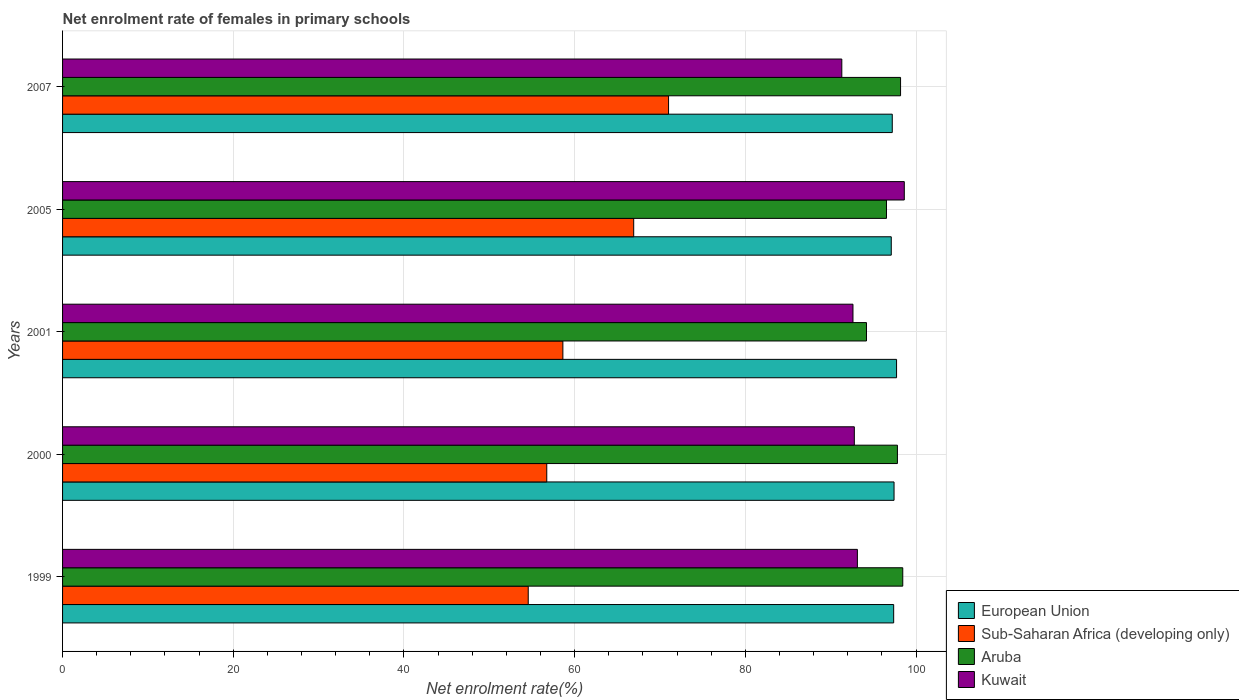How many groups of bars are there?
Provide a short and direct response. 5. Are the number of bars on each tick of the Y-axis equal?
Offer a terse response. Yes. What is the net enrolment rate of females in primary schools in Sub-Saharan Africa (developing only) in 2007?
Keep it short and to the point. 71.01. Across all years, what is the maximum net enrolment rate of females in primary schools in Kuwait?
Offer a very short reply. 98.63. Across all years, what is the minimum net enrolment rate of females in primary schools in Kuwait?
Ensure brevity in your answer.  91.31. In which year was the net enrolment rate of females in primary schools in Aruba maximum?
Keep it short and to the point. 1999. In which year was the net enrolment rate of females in primary schools in European Union minimum?
Keep it short and to the point. 2005. What is the total net enrolment rate of females in primary schools in Sub-Saharan Africa (developing only) in the graph?
Ensure brevity in your answer.  307.85. What is the difference between the net enrolment rate of females in primary schools in European Union in 2000 and that in 2005?
Provide a succinct answer. 0.33. What is the difference between the net enrolment rate of females in primary schools in Kuwait in 2007 and the net enrolment rate of females in primary schools in Aruba in 2001?
Provide a short and direct response. -2.89. What is the average net enrolment rate of females in primary schools in Kuwait per year?
Provide a short and direct response. 93.69. In the year 1999, what is the difference between the net enrolment rate of females in primary schools in Sub-Saharan Africa (developing only) and net enrolment rate of females in primary schools in European Union?
Provide a succinct answer. -42.82. In how many years, is the net enrolment rate of females in primary schools in Sub-Saharan Africa (developing only) greater than 64 %?
Give a very brief answer. 2. What is the ratio of the net enrolment rate of females in primary schools in Sub-Saharan Africa (developing only) in 2001 to that in 2005?
Offer a very short reply. 0.88. What is the difference between the highest and the second highest net enrolment rate of females in primary schools in European Union?
Keep it short and to the point. 0.3. What is the difference between the highest and the lowest net enrolment rate of females in primary schools in Sub-Saharan Africa (developing only)?
Offer a very short reply. 16.44. Is the sum of the net enrolment rate of females in primary schools in European Union in 2000 and 2001 greater than the maximum net enrolment rate of females in primary schools in Sub-Saharan Africa (developing only) across all years?
Your answer should be very brief. Yes. What does the 1st bar from the top in 2000 represents?
Your answer should be very brief. Kuwait. What does the 3rd bar from the bottom in 2000 represents?
Ensure brevity in your answer.  Aruba. How many bars are there?
Make the answer very short. 20. What is the difference between two consecutive major ticks on the X-axis?
Your answer should be very brief. 20. Does the graph contain any zero values?
Keep it short and to the point. No. Where does the legend appear in the graph?
Make the answer very short. Bottom right. What is the title of the graph?
Ensure brevity in your answer.  Net enrolment rate of females in primary schools. Does "Mexico" appear as one of the legend labels in the graph?
Make the answer very short. No. What is the label or title of the X-axis?
Offer a terse response. Net enrolment rate(%). What is the label or title of the Y-axis?
Ensure brevity in your answer.  Years. What is the Net enrolment rate(%) in European Union in 1999?
Offer a very short reply. 97.38. What is the Net enrolment rate(%) of Sub-Saharan Africa (developing only) in 1999?
Offer a very short reply. 54.56. What is the Net enrolment rate(%) in Aruba in 1999?
Keep it short and to the point. 98.45. What is the Net enrolment rate(%) in Kuwait in 1999?
Your response must be concise. 93.13. What is the Net enrolment rate(%) of European Union in 2000?
Offer a terse response. 97.43. What is the Net enrolment rate(%) of Sub-Saharan Africa (developing only) in 2000?
Keep it short and to the point. 56.74. What is the Net enrolment rate(%) of Aruba in 2000?
Make the answer very short. 97.82. What is the Net enrolment rate(%) of Kuwait in 2000?
Provide a succinct answer. 92.77. What is the Net enrolment rate(%) in European Union in 2001?
Offer a terse response. 97.72. What is the Net enrolment rate(%) in Sub-Saharan Africa (developing only) in 2001?
Make the answer very short. 58.62. What is the Net enrolment rate(%) in Aruba in 2001?
Provide a short and direct response. 94.2. What is the Net enrolment rate(%) in Kuwait in 2001?
Your answer should be very brief. 92.62. What is the Net enrolment rate(%) of European Union in 2005?
Keep it short and to the point. 97.1. What is the Net enrolment rate(%) of Sub-Saharan Africa (developing only) in 2005?
Give a very brief answer. 66.92. What is the Net enrolment rate(%) of Aruba in 2005?
Your answer should be compact. 96.54. What is the Net enrolment rate(%) of Kuwait in 2005?
Provide a short and direct response. 98.63. What is the Net enrolment rate(%) of European Union in 2007?
Your answer should be very brief. 97.22. What is the Net enrolment rate(%) of Sub-Saharan Africa (developing only) in 2007?
Offer a terse response. 71.01. What is the Net enrolment rate(%) in Aruba in 2007?
Keep it short and to the point. 98.19. What is the Net enrolment rate(%) of Kuwait in 2007?
Provide a short and direct response. 91.31. Across all years, what is the maximum Net enrolment rate(%) in European Union?
Offer a very short reply. 97.72. Across all years, what is the maximum Net enrolment rate(%) of Sub-Saharan Africa (developing only)?
Give a very brief answer. 71.01. Across all years, what is the maximum Net enrolment rate(%) in Aruba?
Provide a succinct answer. 98.45. Across all years, what is the maximum Net enrolment rate(%) of Kuwait?
Make the answer very short. 98.63. Across all years, what is the minimum Net enrolment rate(%) in European Union?
Make the answer very short. 97.1. Across all years, what is the minimum Net enrolment rate(%) of Sub-Saharan Africa (developing only)?
Your response must be concise. 54.56. Across all years, what is the minimum Net enrolment rate(%) in Aruba?
Give a very brief answer. 94.2. Across all years, what is the minimum Net enrolment rate(%) of Kuwait?
Your response must be concise. 91.31. What is the total Net enrolment rate(%) in European Union in the graph?
Offer a terse response. 486.85. What is the total Net enrolment rate(%) of Sub-Saharan Africa (developing only) in the graph?
Give a very brief answer. 307.85. What is the total Net enrolment rate(%) in Aruba in the graph?
Your response must be concise. 485.2. What is the total Net enrolment rate(%) of Kuwait in the graph?
Keep it short and to the point. 468.46. What is the difference between the Net enrolment rate(%) in European Union in 1999 and that in 2000?
Ensure brevity in your answer.  -0.04. What is the difference between the Net enrolment rate(%) in Sub-Saharan Africa (developing only) in 1999 and that in 2000?
Make the answer very short. -2.17. What is the difference between the Net enrolment rate(%) of Aruba in 1999 and that in 2000?
Make the answer very short. 0.63. What is the difference between the Net enrolment rate(%) in Kuwait in 1999 and that in 2000?
Your answer should be very brief. 0.36. What is the difference between the Net enrolment rate(%) in European Union in 1999 and that in 2001?
Give a very brief answer. -0.34. What is the difference between the Net enrolment rate(%) of Sub-Saharan Africa (developing only) in 1999 and that in 2001?
Your answer should be compact. -4.06. What is the difference between the Net enrolment rate(%) of Aruba in 1999 and that in 2001?
Your response must be concise. 4.25. What is the difference between the Net enrolment rate(%) in Kuwait in 1999 and that in 2001?
Make the answer very short. 0.52. What is the difference between the Net enrolment rate(%) of European Union in 1999 and that in 2005?
Give a very brief answer. 0.28. What is the difference between the Net enrolment rate(%) of Sub-Saharan Africa (developing only) in 1999 and that in 2005?
Your answer should be compact. -12.36. What is the difference between the Net enrolment rate(%) in Aruba in 1999 and that in 2005?
Your response must be concise. 1.91. What is the difference between the Net enrolment rate(%) of Kuwait in 1999 and that in 2005?
Your response must be concise. -5.5. What is the difference between the Net enrolment rate(%) of European Union in 1999 and that in 2007?
Give a very brief answer. 0.17. What is the difference between the Net enrolment rate(%) of Sub-Saharan Africa (developing only) in 1999 and that in 2007?
Offer a terse response. -16.44. What is the difference between the Net enrolment rate(%) in Aruba in 1999 and that in 2007?
Your answer should be compact. 0.26. What is the difference between the Net enrolment rate(%) of Kuwait in 1999 and that in 2007?
Give a very brief answer. 1.83. What is the difference between the Net enrolment rate(%) of European Union in 2000 and that in 2001?
Give a very brief answer. -0.3. What is the difference between the Net enrolment rate(%) of Sub-Saharan Africa (developing only) in 2000 and that in 2001?
Your answer should be very brief. -1.89. What is the difference between the Net enrolment rate(%) of Aruba in 2000 and that in 2001?
Keep it short and to the point. 3.62. What is the difference between the Net enrolment rate(%) of Kuwait in 2000 and that in 2001?
Your answer should be compact. 0.16. What is the difference between the Net enrolment rate(%) in European Union in 2000 and that in 2005?
Your response must be concise. 0.33. What is the difference between the Net enrolment rate(%) in Sub-Saharan Africa (developing only) in 2000 and that in 2005?
Your answer should be compact. -10.19. What is the difference between the Net enrolment rate(%) of Aruba in 2000 and that in 2005?
Provide a short and direct response. 1.28. What is the difference between the Net enrolment rate(%) in Kuwait in 2000 and that in 2005?
Offer a terse response. -5.85. What is the difference between the Net enrolment rate(%) of European Union in 2000 and that in 2007?
Make the answer very short. 0.21. What is the difference between the Net enrolment rate(%) of Sub-Saharan Africa (developing only) in 2000 and that in 2007?
Provide a succinct answer. -14.27. What is the difference between the Net enrolment rate(%) of Aruba in 2000 and that in 2007?
Keep it short and to the point. -0.37. What is the difference between the Net enrolment rate(%) of Kuwait in 2000 and that in 2007?
Your answer should be compact. 1.47. What is the difference between the Net enrolment rate(%) of European Union in 2001 and that in 2005?
Provide a short and direct response. 0.62. What is the difference between the Net enrolment rate(%) of Sub-Saharan Africa (developing only) in 2001 and that in 2005?
Your response must be concise. -8.3. What is the difference between the Net enrolment rate(%) of Aruba in 2001 and that in 2005?
Ensure brevity in your answer.  -2.34. What is the difference between the Net enrolment rate(%) in Kuwait in 2001 and that in 2005?
Offer a very short reply. -6.01. What is the difference between the Net enrolment rate(%) of European Union in 2001 and that in 2007?
Your response must be concise. 0.51. What is the difference between the Net enrolment rate(%) of Sub-Saharan Africa (developing only) in 2001 and that in 2007?
Offer a terse response. -12.38. What is the difference between the Net enrolment rate(%) of Aruba in 2001 and that in 2007?
Offer a terse response. -3.99. What is the difference between the Net enrolment rate(%) in Kuwait in 2001 and that in 2007?
Ensure brevity in your answer.  1.31. What is the difference between the Net enrolment rate(%) in European Union in 2005 and that in 2007?
Your response must be concise. -0.12. What is the difference between the Net enrolment rate(%) in Sub-Saharan Africa (developing only) in 2005 and that in 2007?
Your answer should be compact. -4.08. What is the difference between the Net enrolment rate(%) in Aruba in 2005 and that in 2007?
Provide a succinct answer. -1.65. What is the difference between the Net enrolment rate(%) in Kuwait in 2005 and that in 2007?
Give a very brief answer. 7.32. What is the difference between the Net enrolment rate(%) in European Union in 1999 and the Net enrolment rate(%) in Sub-Saharan Africa (developing only) in 2000?
Give a very brief answer. 40.65. What is the difference between the Net enrolment rate(%) in European Union in 1999 and the Net enrolment rate(%) in Aruba in 2000?
Keep it short and to the point. -0.44. What is the difference between the Net enrolment rate(%) in European Union in 1999 and the Net enrolment rate(%) in Kuwait in 2000?
Your response must be concise. 4.61. What is the difference between the Net enrolment rate(%) of Sub-Saharan Africa (developing only) in 1999 and the Net enrolment rate(%) of Aruba in 2000?
Ensure brevity in your answer.  -43.26. What is the difference between the Net enrolment rate(%) in Sub-Saharan Africa (developing only) in 1999 and the Net enrolment rate(%) in Kuwait in 2000?
Your answer should be very brief. -38.21. What is the difference between the Net enrolment rate(%) in Aruba in 1999 and the Net enrolment rate(%) in Kuwait in 2000?
Give a very brief answer. 5.68. What is the difference between the Net enrolment rate(%) of European Union in 1999 and the Net enrolment rate(%) of Sub-Saharan Africa (developing only) in 2001?
Ensure brevity in your answer.  38.76. What is the difference between the Net enrolment rate(%) of European Union in 1999 and the Net enrolment rate(%) of Aruba in 2001?
Give a very brief answer. 3.18. What is the difference between the Net enrolment rate(%) in European Union in 1999 and the Net enrolment rate(%) in Kuwait in 2001?
Provide a succinct answer. 4.77. What is the difference between the Net enrolment rate(%) in Sub-Saharan Africa (developing only) in 1999 and the Net enrolment rate(%) in Aruba in 2001?
Provide a short and direct response. -39.63. What is the difference between the Net enrolment rate(%) of Sub-Saharan Africa (developing only) in 1999 and the Net enrolment rate(%) of Kuwait in 2001?
Give a very brief answer. -38.05. What is the difference between the Net enrolment rate(%) of Aruba in 1999 and the Net enrolment rate(%) of Kuwait in 2001?
Provide a succinct answer. 5.83. What is the difference between the Net enrolment rate(%) in European Union in 1999 and the Net enrolment rate(%) in Sub-Saharan Africa (developing only) in 2005?
Provide a short and direct response. 30.46. What is the difference between the Net enrolment rate(%) in European Union in 1999 and the Net enrolment rate(%) in Aruba in 2005?
Your answer should be very brief. 0.84. What is the difference between the Net enrolment rate(%) of European Union in 1999 and the Net enrolment rate(%) of Kuwait in 2005?
Make the answer very short. -1.25. What is the difference between the Net enrolment rate(%) of Sub-Saharan Africa (developing only) in 1999 and the Net enrolment rate(%) of Aruba in 2005?
Ensure brevity in your answer.  -41.98. What is the difference between the Net enrolment rate(%) in Sub-Saharan Africa (developing only) in 1999 and the Net enrolment rate(%) in Kuwait in 2005?
Provide a short and direct response. -44.07. What is the difference between the Net enrolment rate(%) in Aruba in 1999 and the Net enrolment rate(%) in Kuwait in 2005?
Offer a terse response. -0.18. What is the difference between the Net enrolment rate(%) of European Union in 1999 and the Net enrolment rate(%) of Sub-Saharan Africa (developing only) in 2007?
Offer a terse response. 26.38. What is the difference between the Net enrolment rate(%) of European Union in 1999 and the Net enrolment rate(%) of Aruba in 2007?
Provide a succinct answer. -0.81. What is the difference between the Net enrolment rate(%) in European Union in 1999 and the Net enrolment rate(%) in Kuwait in 2007?
Your answer should be compact. 6.08. What is the difference between the Net enrolment rate(%) in Sub-Saharan Africa (developing only) in 1999 and the Net enrolment rate(%) in Aruba in 2007?
Offer a very short reply. -43.63. What is the difference between the Net enrolment rate(%) in Sub-Saharan Africa (developing only) in 1999 and the Net enrolment rate(%) in Kuwait in 2007?
Give a very brief answer. -36.74. What is the difference between the Net enrolment rate(%) of Aruba in 1999 and the Net enrolment rate(%) of Kuwait in 2007?
Provide a short and direct response. 7.14. What is the difference between the Net enrolment rate(%) in European Union in 2000 and the Net enrolment rate(%) in Sub-Saharan Africa (developing only) in 2001?
Your answer should be very brief. 38.81. What is the difference between the Net enrolment rate(%) in European Union in 2000 and the Net enrolment rate(%) in Aruba in 2001?
Keep it short and to the point. 3.23. What is the difference between the Net enrolment rate(%) of European Union in 2000 and the Net enrolment rate(%) of Kuwait in 2001?
Keep it short and to the point. 4.81. What is the difference between the Net enrolment rate(%) in Sub-Saharan Africa (developing only) in 2000 and the Net enrolment rate(%) in Aruba in 2001?
Your answer should be very brief. -37.46. What is the difference between the Net enrolment rate(%) of Sub-Saharan Africa (developing only) in 2000 and the Net enrolment rate(%) of Kuwait in 2001?
Your answer should be very brief. -35.88. What is the difference between the Net enrolment rate(%) of Aruba in 2000 and the Net enrolment rate(%) of Kuwait in 2001?
Give a very brief answer. 5.21. What is the difference between the Net enrolment rate(%) in European Union in 2000 and the Net enrolment rate(%) in Sub-Saharan Africa (developing only) in 2005?
Your answer should be compact. 30.5. What is the difference between the Net enrolment rate(%) in European Union in 2000 and the Net enrolment rate(%) in Aruba in 2005?
Ensure brevity in your answer.  0.89. What is the difference between the Net enrolment rate(%) in European Union in 2000 and the Net enrolment rate(%) in Kuwait in 2005?
Make the answer very short. -1.2. What is the difference between the Net enrolment rate(%) in Sub-Saharan Africa (developing only) in 2000 and the Net enrolment rate(%) in Aruba in 2005?
Offer a very short reply. -39.81. What is the difference between the Net enrolment rate(%) of Sub-Saharan Africa (developing only) in 2000 and the Net enrolment rate(%) of Kuwait in 2005?
Offer a very short reply. -41.89. What is the difference between the Net enrolment rate(%) in Aruba in 2000 and the Net enrolment rate(%) in Kuwait in 2005?
Ensure brevity in your answer.  -0.81. What is the difference between the Net enrolment rate(%) in European Union in 2000 and the Net enrolment rate(%) in Sub-Saharan Africa (developing only) in 2007?
Offer a very short reply. 26.42. What is the difference between the Net enrolment rate(%) of European Union in 2000 and the Net enrolment rate(%) of Aruba in 2007?
Keep it short and to the point. -0.76. What is the difference between the Net enrolment rate(%) in European Union in 2000 and the Net enrolment rate(%) in Kuwait in 2007?
Provide a short and direct response. 6.12. What is the difference between the Net enrolment rate(%) of Sub-Saharan Africa (developing only) in 2000 and the Net enrolment rate(%) of Aruba in 2007?
Make the answer very short. -41.46. What is the difference between the Net enrolment rate(%) in Sub-Saharan Africa (developing only) in 2000 and the Net enrolment rate(%) in Kuwait in 2007?
Your response must be concise. -34.57. What is the difference between the Net enrolment rate(%) in Aruba in 2000 and the Net enrolment rate(%) in Kuwait in 2007?
Offer a very short reply. 6.52. What is the difference between the Net enrolment rate(%) in European Union in 2001 and the Net enrolment rate(%) in Sub-Saharan Africa (developing only) in 2005?
Keep it short and to the point. 30.8. What is the difference between the Net enrolment rate(%) in European Union in 2001 and the Net enrolment rate(%) in Aruba in 2005?
Provide a succinct answer. 1.18. What is the difference between the Net enrolment rate(%) of European Union in 2001 and the Net enrolment rate(%) of Kuwait in 2005?
Keep it short and to the point. -0.91. What is the difference between the Net enrolment rate(%) in Sub-Saharan Africa (developing only) in 2001 and the Net enrolment rate(%) in Aruba in 2005?
Make the answer very short. -37.92. What is the difference between the Net enrolment rate(%) in Sub-Saharan Africa (developing only) in 2001 and the Net enrolment rate(%) in Kuwait in 2005?
Give a very brief answer. -40.01. What is the difference between the Net enrolment rate(%) in Aruba in 2001 and the Net enrolment rate(%) in Kuwait in 2005?
Provide a short and direct response. -4.43. What is the difference between the Net enrolment rate(%) of European Union in 2001 and the Net enrolment rate(%) of Sub-Saharan Africa (developing only) in 2007?
Your answer should be compact. 26.72. What is the difference between the Net enrolment rate(%) in European Union in 2001 and the Net enrolment rate(%) in Aruba in 2007?
Ensure brevity in your answer.  -0.47. What is the difference between the Net enrolment rate(%) in European Union in 2001 and the Net enrolment rate(%) in Kuwait in 2007?
Your response must be concise. 6.42. What is the difference between the Net enrolment rate(%) of Sub-Saharan Africa (developing only) in 2001 and the Net enrolment rate(%) of Aruba in 2007?
Provide a short and direct response. -39.57. What is the difference between the Net enrolment rate(%) in Sub-Saharan Africa (developing only) in 2001 and the Net enrolment rate(%) in Kuwait in 2007?
Provide a short and direct response. -32.68. What is the difference between the Net enrolment rate(%) of Aruba in 2001 and the Net enrolment rate(%) of Kuwait in 2007?
Provide a succinct answer. 2.89. What is the difference between the Net enrolment rate(%) in European Union in 2005 and the Net enrolment rate(%) in Sub-Saharan Africa (developing only) in 2007?
Provide a succinct answer. 26.1. What is the difference between the Net enrolment rate(%) in European Union in 2005 and the Net enrolment rate(%) in Aruba in 2007?
Provide a succinct answer. -1.09. What is the difference between the Net enrolment rate(%) in European Union in 2005 and the Net enrolment rate(%) in Kuwait in 2007?
Offer a very short reply. 5.8. What is the difference between the Net enrolment rate(%) of Sub-Saharan Africa (developing only) in 2005 and the Net enrolment rate(%) of Aruba in 2007?
Offer a very short reply. -31.27. What is the difference between the Net enrolment rate(%) of Sub-Saharan Africa (developing only) in 2005 and the Net enrolment rate(%) of Kuwait in 2007?
Provide a succinct answer. -24.38. What is the difference between the Net enrolment rate(%) in Aruba in 2005 and the Net enrolment rate(%) in Kuwait in 2007?
Give a very brief answer. 5.23. What is the average Net enrolment rate(%) in European Union per year?
Your answer should be compact. 97.37. What is the average Net enrolment rate(%) in Sub-Saharan Africa (developing only) per year?
Your answer should be very brief. 61.57. What is the average Net enrolment rate(%) of Aruba per year?
Give a very brief answer. 97.04. What is the average Net enrolment rate(%) in Kuwait per year?
Ensure brevity in your answer.  93.69. In the year 1999, what is the difference between the Net enrolment rate(%) in European Union and Net enrolment rate(%) in Sub-Saharan Africa (developing only)?
Offer a terse response. 42.82. In the year 1999, what is the difference between the Net enrolment rate(%) of European Union and Net enrolment rate(%) of Aruba?
Your response must be concise. -1.07. In the year 1999, what is the difference between the Net enrolment rate(%) of European Union and Net enrolment rate(%) of Kuwait?
Offer a very short reply. 4.25. In the year 1999, what is the difference between the Net enrolment rate(%) of Sub-Saharan Africa (developing only) and Net enrolment rate(%) of Aruba?
Offer a terse response. -43.89. In the year 1999, what is the difference between the Net enrolment rate(%) of Sub-Saharan Africa (developing only) and Net enrolment rate(%) of Kuwait?
Your answer should be very brief. -38.57. In the year 1999, what is the difference between the Net enrolment rate(%) in Aruba and Net enrolment rate(%) in Kuwait?
Offer a terse response. 5.32. In the year 2000, what is the difference between the Net enrolment rate(%) of European Union and Net enrolment rate(%) of Sub-Saharan Africa (developing only)?
Provide a succinct answer. 40.69. In the year 2000, what is the difference between the Net enrolment rate(%) of European Union and Net enrolment rate(%) of Aruba?
Your response must be concise. -0.4. In the year 2000, what is the difference between the Net enrolment rate(%) of European Union and Net enrolment rate(%) of Kuwait?
Ensure brevity in your answer.  4.65. In the year 2000, what is the difference between the Net enrolment rate(%) in Sub-Saharan Africa (developing only) and Net enrolment rate(%) in Aruba?
Your response must be concise. -41.09. In the year 2000, what is the difference between the Net enrolment rate(%) in Sub-Saharan Africa (developing only) and Net enrolment rate(%) in Kuwait?
Your response must be concise. -36.04. In the year 2000, what is the difference between the Net enrolment rate(%) in Aruba and Net enrolment rate(%) in Kuwait?
Offer a terse response. 5.05. In the year 2001, what is the difference between the Net enrolment rate(%) of European Union and Net enrolment rate(%) of Sub-Saharan Africa (developing only)?
Keep it short and to the point. 39.1. In the year 2001, what is the difference between the Net enrolment rate(%) in European Union and Net enrolment rate(%) in Aruba?
Provide a succinct answer. 3.53. In the year 2001, what is the difference between the Net enrolment rate(%) of European Union and Net enrolment rate(%) of Kuwait?
Provide a succinct answer. 5.11. In the year 2001, what is the difference between the Net enrolment rate(%) of Sub-Saharan Africa (developing only) and Net enrolment rate(%) of Aruba?
Make the answer very short. -35.58. In the year 2001, what is the difference between the Net enrolment rate(%) in Sub-Saharan Africa (developing only) and Net enrolment rate(%) in Kuwait?
Make the answer very short. -33.99. In the year 2001, what is the difference between the Net enrolment rate(%) of Aruba and Net enrolment rate(%) of Kuwait?
Make the answer very short. 1.58. In the year 2005, what is the difference between the Net enrolment rate(%) in European Union and Net enrolment rate(%) in Sub-Saharan Africa (developing only)?
Give a very brief answer. 30.18. In the year 2005, what is the difference between the Net enrolment rate(%) of European Union and Net enrolment rate(%) of Aruba?
Keep it short and to the point. 0.56. In the year 2005, what is the difference between the Net enrolment rate(%) of European Union and Net enrolment rate(%) of Kuwait?
Ensure brevity in your answer.  -1.53. In the year 2005, what is the difference between the Net enrolment rate(%) in Sub-Saharan Africa (developing only) and Net enrolment rate(%) in Aruba?
Offer a terse response. -29.62. In the year 2005, what is the difference between the Net enrolment rate(%) in Sub-Saharan Africa (developing only) and Net enrolment rate(%) in Kuwait?
Give a very brief answer. -31.71. In the year 2005, what is the difference between the Net enrolment rate(%) of Aruba and Net enrolment rate(%) of Kuwait?
Ensure brevity in your answer.  -2.09. In the year 2007, what is the difference between the Net enrolment rate(%) in European Union and Net enrolment rate(%) in Sub-Saharan Africa (developing only)?
Provide a succinct answer. 26.21. In the year 2007, what is the difference between the Net enrolment rate(%) of European Union and Net enrolment rate(%) of Aruba?
Your answer should be very brief. -0.97. In the year 2007, what is the difference between the Net enrolment rate(%) in European Union and Net enrolment rate(%) in Kuwait?
Provide a short and direct response. 5.91. In the year 2007, what is the difference between the Net enrolment rate(%) of Sub-Saharan Africa (developing only) and Net enrolment rate(%) of Aruba?
Keep it short and to the point. -27.18. In the year 2007, what is the difference between the Net enrolment rate(%) of Sub-Saharan Africa (developing only) and Net enrolment rate(%) of Kuwait?
Ensure brevity in your answer.  -20.3. In the year 2007, what is the difference between the Net enrolment rate(%) of Aruba and Net enrolment rate(%) of Kuwait?
Give a very brief answer. 6.88. What is the ratio of the Net enrolment rate(%) in European Union in 1999 to that in 2000?
Your answer should be very brief. 1. What is the ratio of the Net enrolment rate(%) in Sub-Saharan Africa (developing only) in 1999 to that in 2000?
Your response must be concise. 0.96. What is the ratio of the Net enrolment rate(%) of Aruba in 1999 to that in 2000?
Make the answer very short. 1.01. What is the ratio of the Net enrolment rate(%) of European Union in 1999 to that in 2001?
Keep it short and to the point. 1. What is the ratio of the Net enrolment rate(%) in Sub-Saharan Africa (developing only) in 1999 to that in 2001?
Give a very brief answer. 0.93. What is the ratio of the Net enrolment rate(%) in Aruba in 1999 to that in 2001?
Give a very brief answer. 1.05. What is the ratio of the Net enrolment rate(%) in Kuwait in 1999 to that in 2001?
Make the answer very short. 1.01. What is the ratio of the Net enrolment rate(%) in Sub-Saharan Africa (developing only) in 1999 to that in 2005?
Your answer should be compact. 0.82. What is the ratio of the Net enrolment rate(%) of Aruba in 1999 to that in 2005?
Your response must be concise. 1.02. What is the ratio of the Net enrolment rate(%) in Kuwait in 1999 to that in 2005?
Offer a terse response. 0.94. What is the ratio of the Net enrolment rate(%) in Sub-Saharan Africa (developing only) in 1999 to that in 2007?
Provide a succinct answer. 0.77. What is the ratio of the Net enrolment rate(%) in Sub-Saharan Africa (developing only) in 2000 to that in 2001?
Ensure brevity in your answer.  0.97. What is the ratio of the Net enrolment rate(%) in European Union in 2000 to that in 2005?
Your response must be concise. 1. What is the ratio of the Net enrolment rate(%) in Sub-Saharan Africa (developing only) in 2000 to that in 2005?
Offer a very short reply. 0.85. What is the ratio of the Net enrolment rate(%) of Aruba in 2000 to that in 2005?
Your response must be concise. 1.01. What is the ratio of the Net enrolment rate(%) in Kuwait in 2000 to that in 2005?
Provide a succinct answer. 0.94. What is the ratio of the Net enrolment rate(%) of European Union in 2000 to that in 2007?
Provide a short and direct response. 1. What is the ratio of the Net enrolment rate(%) in Sub-Saharan Africa (developing only) in 2000 to that in 2007?
Provide a succinct answer. 0.8. What is the ratio of the Net enrolment rate(%) of Kuwait in 2000 to that in 2007?
Keep it short and to the point. 1.02. What is the ratio of the Net enrolment rate(%) of European Union in 2001 to that in 2005?
Offer a terse response. 1.01. What is the ratio of the Net enrolment rate(%) in Sub-Saharan Africa (developing only) in 2001 to that in 2005?
Give a very brief answer. 0.88. What is the ratio of the Net enrolment rate(%) in Aruba in 2001 to that in 2005?
Offer a terse response. 0.98. What is the ratio of the Net enrolment rate(%) of Kuwait in 2001 to that in 2005?
Provide a short and direct response. 0.94. What is the ratio of the Net enrolment rate(%) of Sub-Saharan Africa (developing only) in 2001 to that in 2007?
Offer a terse response. 0.83. What is the ratio of the Net enrolment rate(%) of Aruba in 2001 to that in 2007?
Make the answer very short. 0.96. What is the ratio of the Net enrolment rate(%) of Kuwait in 2001 to that in 2007?
Keep it short and to the point. 1.01. What is the ratio of the Net enrolment rate(%) of Sub-Saharan Africa (developing only) in 2005 to that in 2007?
Make the answer very short. 0.94. What is the ratio of the Net enrolment rate(%) in Aruba in 2005 to that in 2007?
Ensure brevity in your answer.  0.98. What is the ratio of the Net enrolment rate(%) in Kuwait in 2005 to that in 2007?
Offer a terse response. 1.08. What is the difference between the highest and the second highest Net enrolment rate(%) of European Union?
Offer a terse response. 0.3. What is the difference between the highest and the second highest Net enrolment rate(%) in Sub-Saharan Africa (developing only)?
Ensure brevity in your answer.  4.08. What is the difference between the highest and the second highest Net enrolment rate(%) of Aruba?
Provide a short and direct response. 0.26. What is the difference between the highest and the second highest Net enrolment rate(%) in Kuwait?
Your answer should be compact. 5.5. What is the difference between the highest and the lowest Net enrolment rate(%) of European Union?
Offer a terse response. 0.62. What is the difference between the highest and the lowest Net enrolment rate(%) of Sub-Saharan Africa (developing only)?
Ensure brevity in your answer.  16.44. What is the difference between the highest and the lowest Net enrolment rate(%) of Aruba?
Provide a succinct answer. 4.25. What is the difference between the highest and the lowest Net enrolment rate(%) in Kuwait?
Keep it short and to the point. 7.32. 